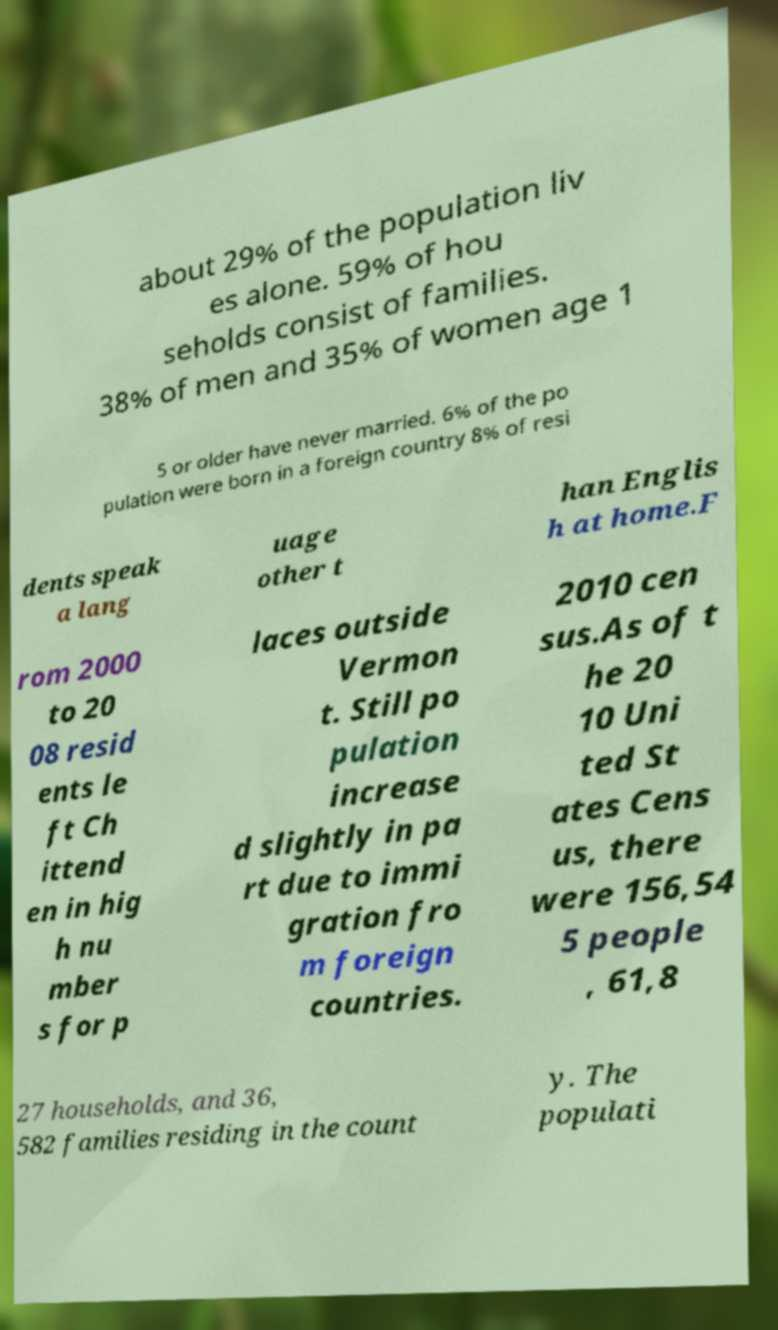What messages or text are displayed in this image? I need them in a readable, typed format. about 29% of the population liv es alone. 59% of hou seholds consist of families. 38% of men and 35% of women age 1 5 or older have never married. 6% of the po pulation were born in a foreign country 8% of resi dents speak a lang uage other t han Englis h at home.F rom 2000 to 20 08 resid ents le ft Ch ittend en in hig h nu mber s for p laces outside Vermon t. Still po pulation increase d slightly in pa rt due to immi gration fro m foreign countries. 2010 cen sus.As of t he 20 10 Uni ted St ates Cens us, there were 156,54 5 people , 61,8 27 households, and 36, 582 families residing in the count y. The populati 